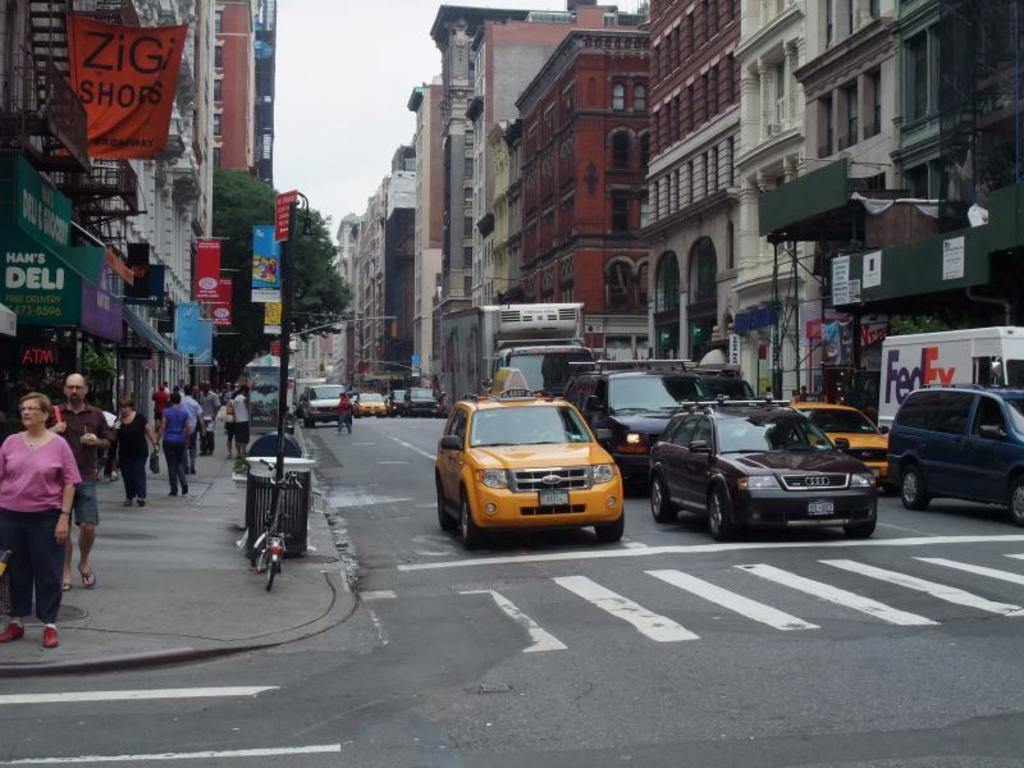<image>
Create a compact narrative representing the image presented. A busy intersection has taxis and a white truck that says FedEx. 